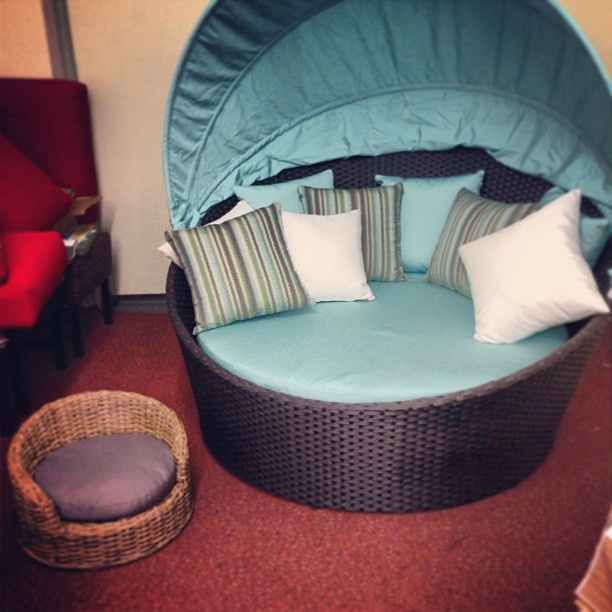Describe the objects in this image and their specific colors. I can see chair in salmon, black, darkgray, gray, and teal tones, bed in salmon, black, darkgray, gray, and teal tones, chair in salmon, brown, maroon, and black tones, and chair in salmon, black, maroon, gray, and brown tones in this image. 